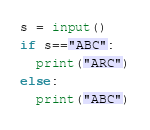<code> <loc_0><loc_0><loc_500><loc_500><_Python_>s = input()
if s=="ABC":
  print("ARC")
else:
  print("ABC")</code> 